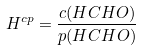<formula> <loc_0><loc_0><loc_500><loc_500>H ^ { c p } = \frac { c ( H C H O ) } { p ( H C H O ) }</formula> 